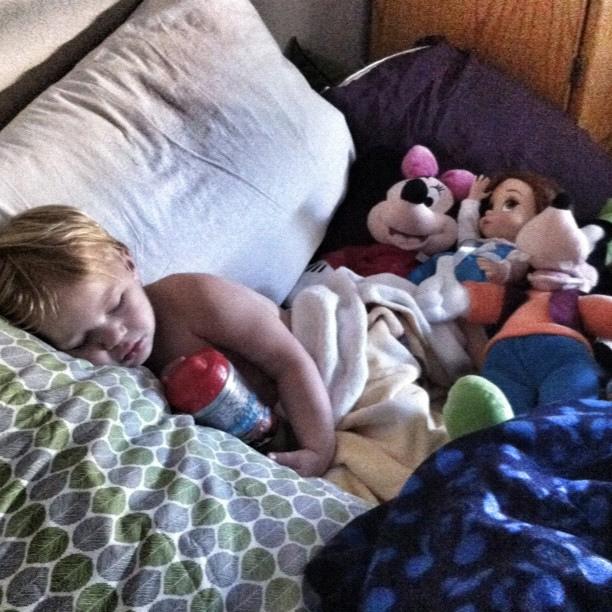How many dolls are in the photo?
Give a very brief answer. 3. How many kids are sleeping in this bed?
Be succinct. 1. Is this kid sleeping?
Concise answer only. Yes. What is the little boy holding?
Be succinct. Sippy cup. 